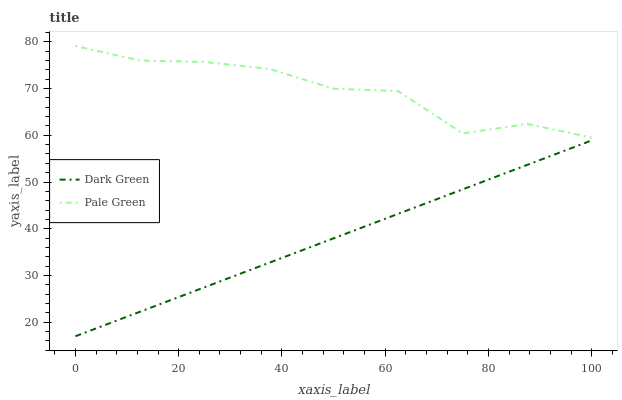Does Dark Green have the minimum area under the curve?
Answer yes or no. Yes. Does Pale Green have the maximum area under the curve?
Answer yes or no. Yes. Does Dark Green have the maximum area under the curve?
Answer yes or no. No. Is Dark Green the smoothest?
Answer yes or no. Yes. Is Pale Green the roughest?
Answer yes or no. Yes. Is Dark Green the roughest?
Answer yes or no. No. Does Dark Green have the lowest value?
Answer yes or no. Yes. Does Pale Green have the highest value?
Answer yes or no. Yes. Does Dark Green have the highest value?
Answer yes or no. No. Is Dark Green less than Pale Green?
Answer yes or no. Yes. Is Pale Green greater than Dark Green?
Answer yes or no. Yes. Does Dark Green intersect Pale Green?
Answer yes or no. No. 